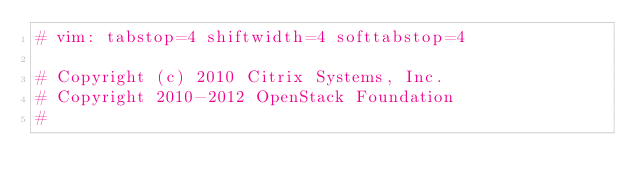<code> <loc_0><loc_0><loc_500><loc_500><_Python_># vim: tabstop=4 shiftwidth=4 softtabstop=4

# Copyright (c) 2010 Citrix Systems, Inc.
# Copyright 2010-2012 OpenStack Foundation
#</code> 